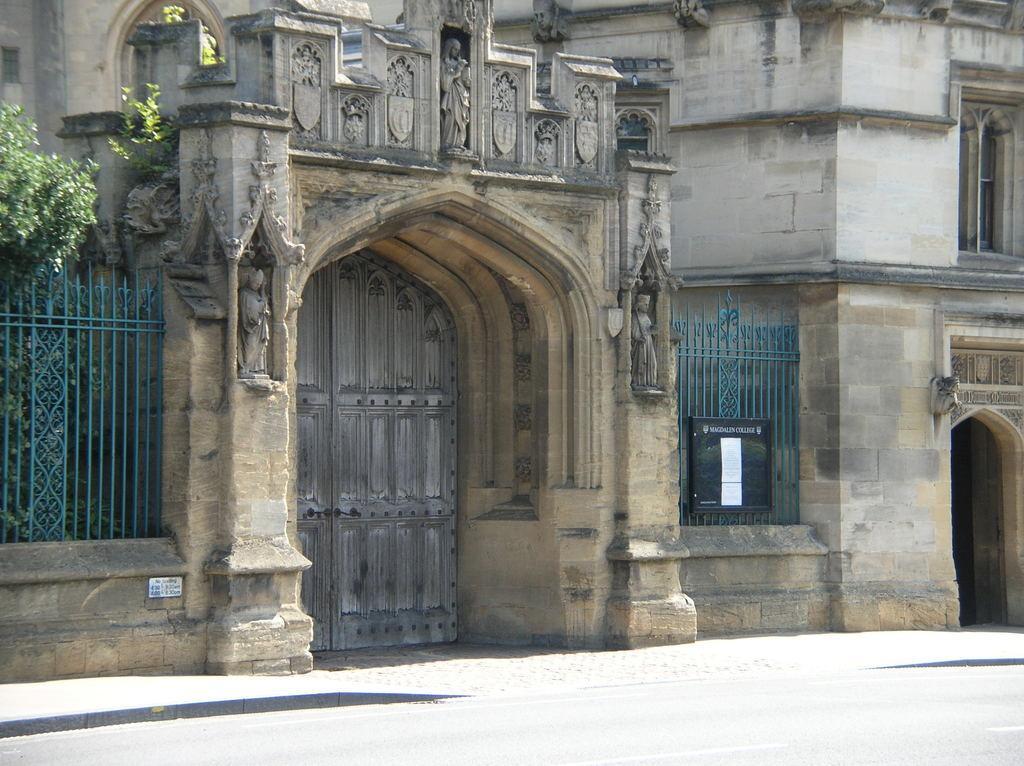In one or two sentences, can you explain what this image depicts? In front of the image there is a road, beside the road there is a pavement, beside the pavement there are a few sculptures on the pillar and on the wall. Beside the pillar there is a metal rod fence, behind the fence there are trees. In front of the fence there is a nameplate on the wall. Between the pillars there is a closed wooden door, on the metal rods there is a board with some posters on it. In the background of the image there is a building. On the right side of the image there is the entrance of the building. 